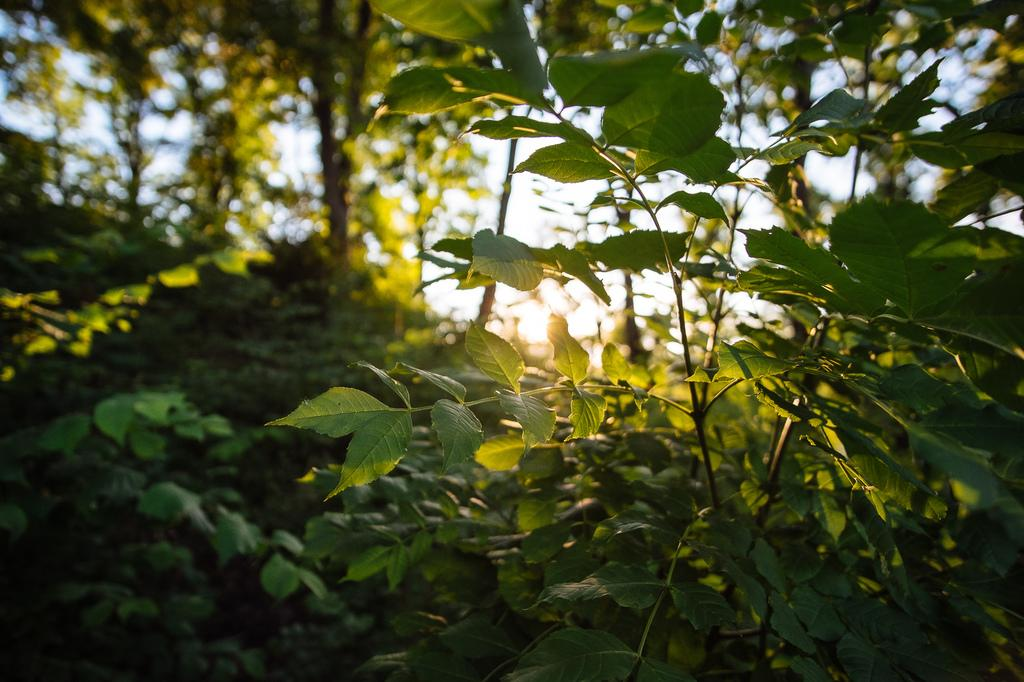What type of living organisms can be seen in the image? Plants and trees are visible in the image. Can you describe the natural setting visible in the image? The natural setting includes plants and trees. What is visible in the sky in the image? The sky is visible in the image. Where is the father sitting on the sofa in the image? There is no father or sofa present in the image; it only features plants, trees, and the sky. 